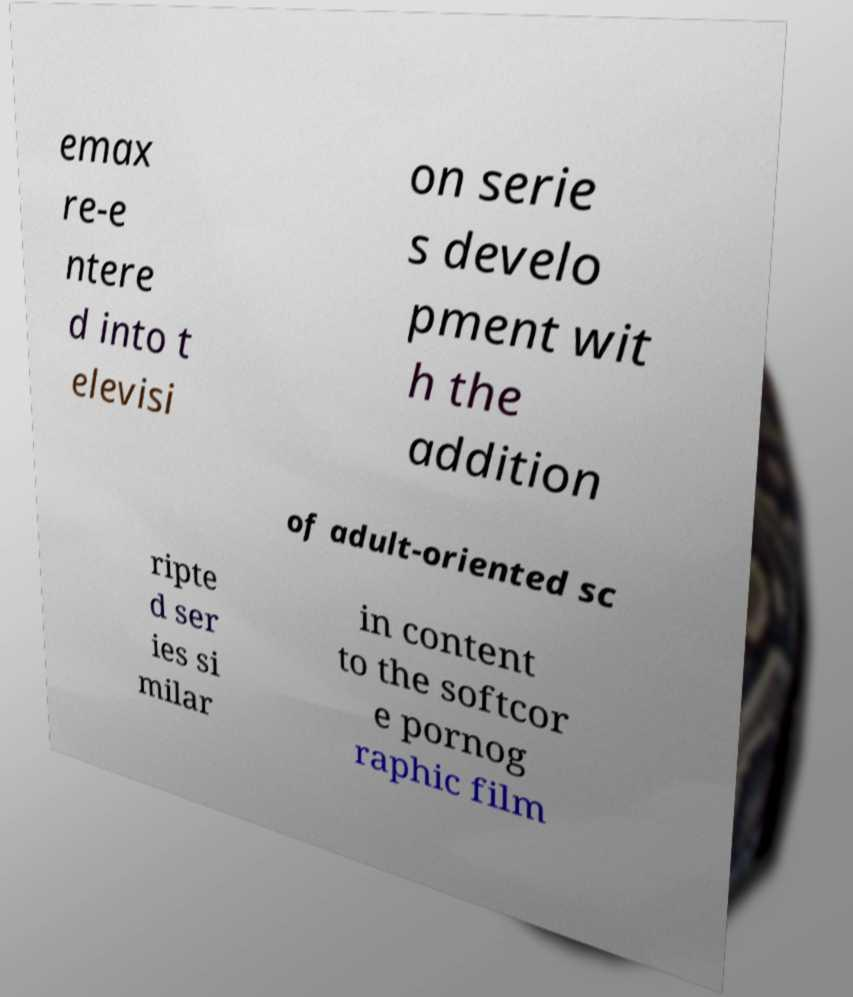Could you extract and type out the text from this image? emax re-e ntere d into t elevisi on serie s develo pment wit h the addition of adult-oriented sc ripte d ser ies si milar in content to the softcor e pornog raphic film 